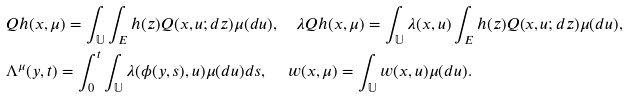<formula> <loc_0><loc_0><loc_500><loc_500>& Q h ( x , \mu ) = \int _ { \mathbb { U } } \int _ { E } h ( z ) Q ( x , u ; d z ) \mu ( d u ) , \quad \lambda Q h ( x , \mu ) = \int _ { \mathbb { U } } \lambda ( x , u ) \int _ { E } h ( z ) Q ( x , u ; d z ) \mu ( d u ) , \\ & \Lambda ^ { \mu } ( y , t ) = \int _ { 0 } ^ { t } \int _ { \mathbb { U } } \lambda ( \phi ( y , s ) , u ) \mu ( d u ) d s , \, \quad w ( x , \mu ) = \int _ { \mathbb { U } } w ( x , u ) \mu ( d u ) . &</formula> 